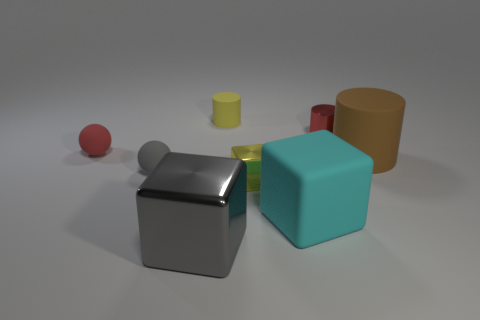Add 1 green rubber cylinders. How many objects exist? 9 Subtract all big brown cylinders. How many cylinders are left? 2 Subtract all cylinders. How many objects are left? 5 Subtract all red balls. How many balls are left? 1 Subtract 2 cylinders. How many cylinders are left? 1 Subtract 0 green spheres. How many objects are left? 8 Subtract all gray balls. Subtract all gray cylinders. How many balls are left? 1 Subtract all small red shiny objects. Subtract all tiny cubes. How many objects are left? 6 Add 7 cyan blocks. How many cyan blocks are left? 8 Add 7 big yellow matte cylinders. How many big yellow matte cylinders exist? 7 